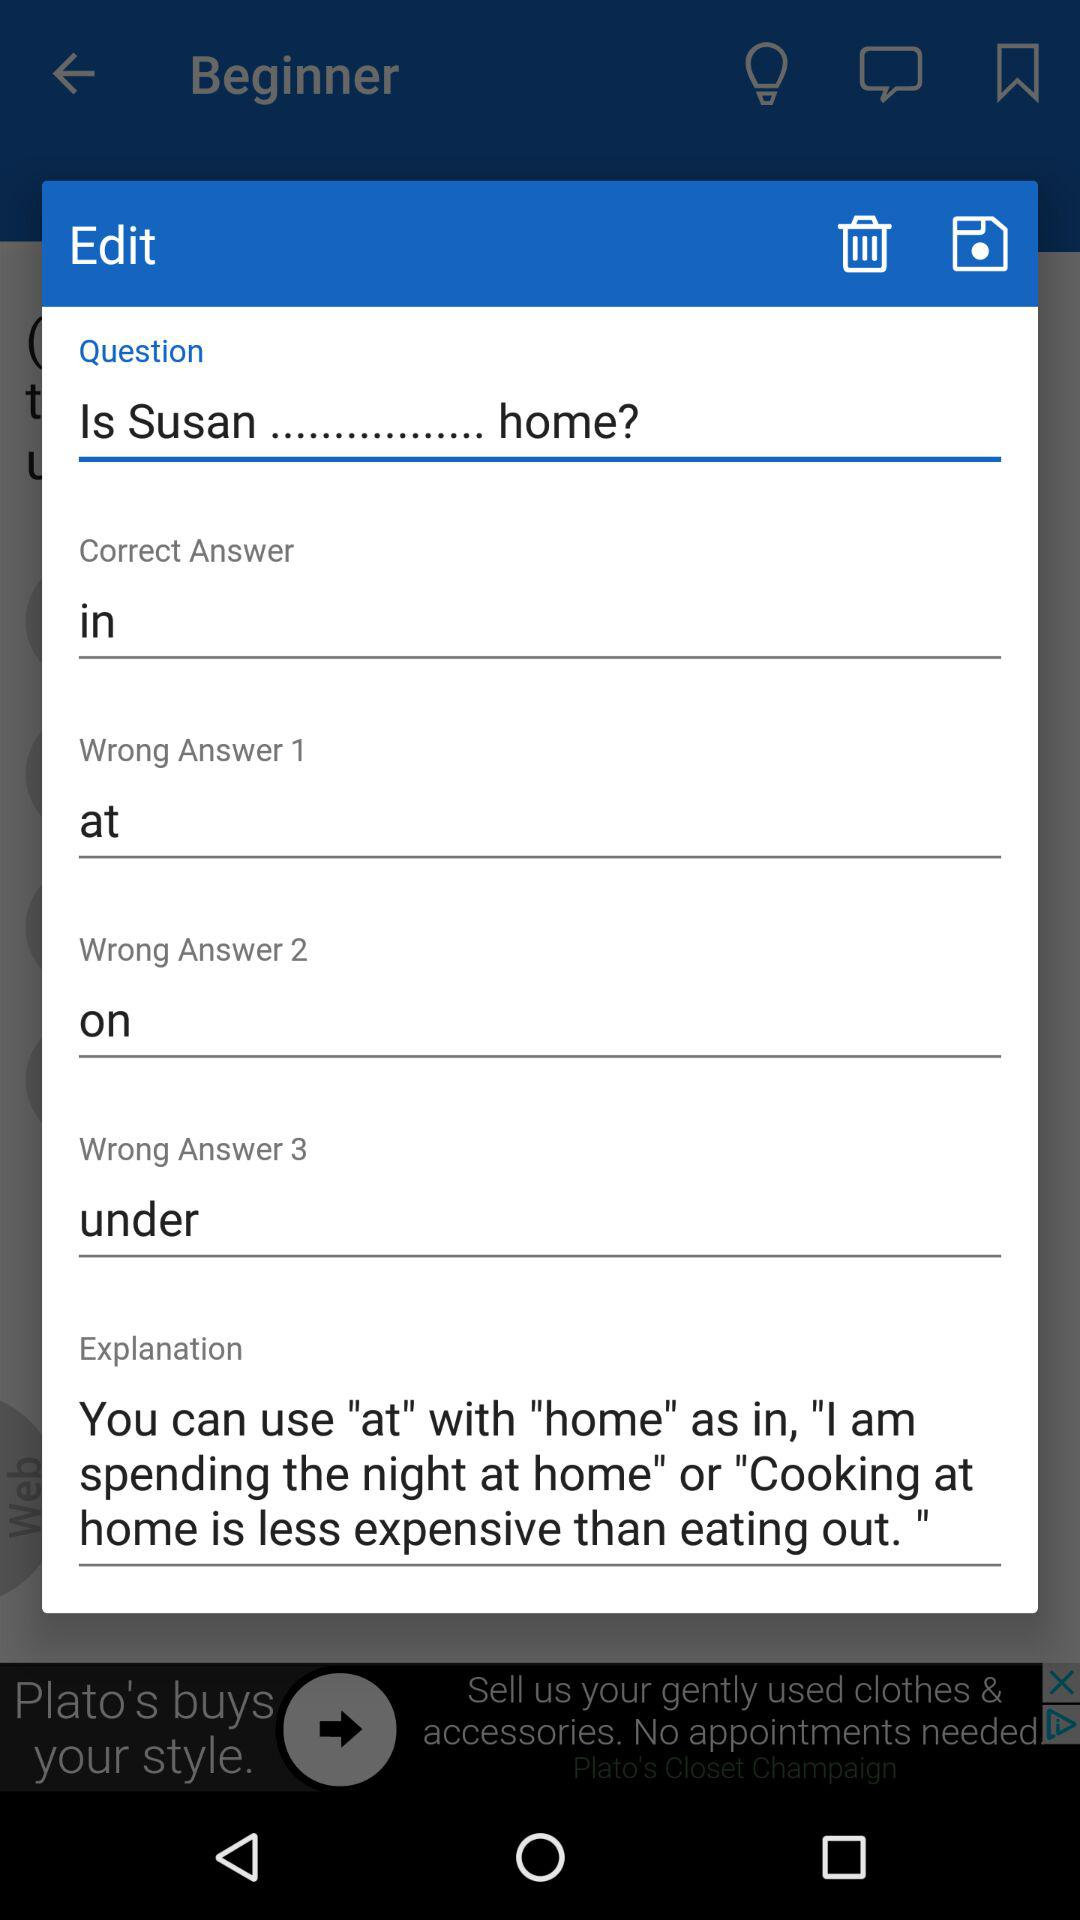How many wrong answers are there in this question?
Answer the question using a single word or phrase. 3 